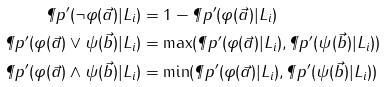<formula> <loc_0><loc_0><loc_500><loc_500>\P p ^ { \prime } ( \neg \varphi ( \vec { a } ) | L _ { i } ) & = 1 - \P p ^ { \prime } ( \varphi ( \vec { a } ) | L _ { i } ) \\ \P p ^ { \prime } ( \varphi ( \vec { a } ) \vee \psi ( \vec { b } ) | L _ { i } ) & = \max ( \P p ^ { \prime } ( \varphi ( \vec { a } ) | L _ { i } ) , \P p ^ { \prime } ( \psi ( \vec { b } ) | L _ { i } ) ) \\ \P p ^ { \prime } ( \varphi ( \vec { a } ) \wedge \psi ( \vec { b } ) | L _ { i } ) & = \min ( \P p ^ { \prime } ( \varphi ( \vec { a } ) | L _ { i } ) , \P p ^ { \prime } ( \psi ( \vec { b } ) | L _ { i } ) )</formula> 